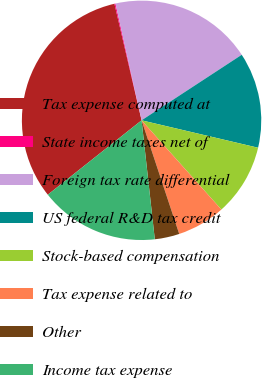<chart> <loc_0><loc_0><loc_500><loc_500><pie_chart><fcel>Tax expense computed at<fcel>State income taxes net of<fcel>Foreign tax rate differential<fcel>US federal R&D tax credit<fcel>Stock-based compensation<fcel>Tax expense related to<fcel>Other<fcel>Income tax expense<nl><fcel>32.03%<fcel>0.14%<fcel>19.28%<fcel>12.9%<fcel>9.71%<fcel>6.52%<fcel>3.33%<fcel>16.09%<nl></chart> 